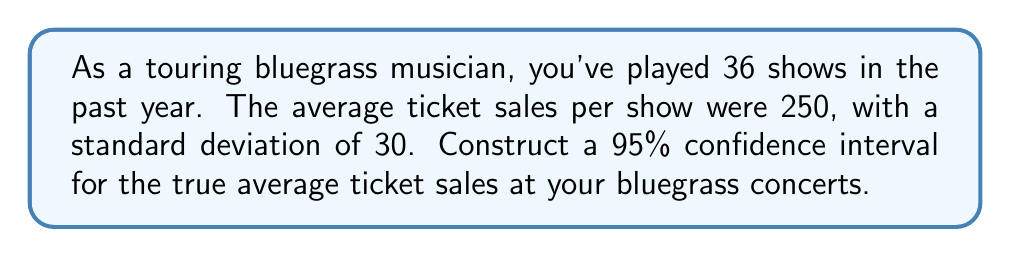Help me with this question. To construct a confidence interval, we'll follow these steps:

1. Identify the given information:
   - Sample size (n) = 36
   - Sample mean (x̄) = 250
   - Sample standard deviation (s) = 30
   - Confidence level = 95%

2. Determine the critical value:
   For a 95% confidence level with df = 35, the t-critical value is approximately 2.030.

3. Calculate the standard error (SE):
   $SE = \frac{s}{\sqrt{n}} = \frac{30}{\sqrt{36}} = 5$

4. Calculate the margin of error (ME):
   $ME = t_{critical} \times SE = 2.030 \times 5 = 10.15$

5. Construct the confidence interval:
   $CI = \bar{x} \pm ME$
   $CI = 250 \pm 10.15$
   $CI = (239.85, 260.15)$

Therefore, we can be 95% confident that the true average ticket sales for your bluegrass concerts fall between 239.85 and 260.15.
Answer: (239.85, 260.15) 